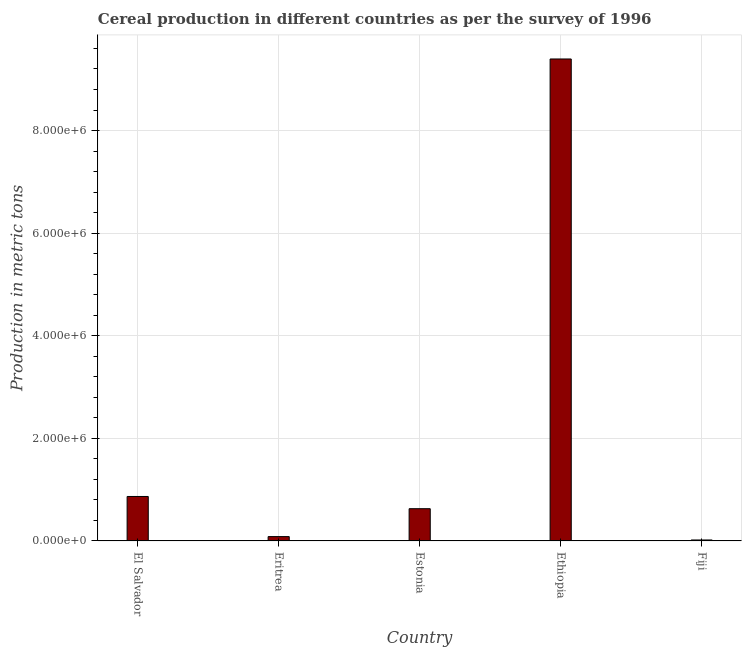Does the graph contain any zero values?
Your answer should be very brief. No. What is the title of the graph?
Offer a terse response. Cereal production in different countries as per the survey of 1996. What is the label or title of the Y-axis?
Offer a very short reply. Production in metric tons. What is the cereal production in Ethiopia?
Provide a succinct answer. 9.39e+06. Across all countries, what is the maximum cereal production?
Provide a succinct answer. 9.39e+06. Across all countries, what is the minimum cereal production?
Your answer should be compact. 1.94e+04. In which country was the cereal production maximum?
Your answer should be very brief. Ethiopia. In which country was the cereal production minimum?
Make the answer very short. Fiji. What is the sum of the cereal production?
Your answer should be very brief. 1.10e+07. What is the difference between the cereal production in El Salvador and Ethiopia?
Keep it short and to the point. -8.53e+06. What is the average cereal production per country?
Keep it short and to the point. 2.20e+06. What is the median cereal production?
Your answer should be very brief. 6.29e+05. What is the ratio of the cereal production in Eritrea to that in Estonia?
Your answer should be compact. 0.14. Is the difference between the cereal production in Eritrea and Ethiopia greater than the difference between any two countries?
Keep it short and to the point. No. What is the difference between the highest and the second highest cereal production?
Provide a short and direct response. 8.53e+06. What is the difference between the highest and the lowest cereal production?
Ensure brevity in your answer.  9.38e+06. In how many countries, is the cereal production greater than the average cereal production taken over all countries?
Provide a short and direct response. 1. Are the values on the major ticks of Y-axis written in scientific E-notation?
Your answer should be very brief. Yes. What is the Production in metric tons in El Salvador?
Offer a terse response. 8.67e+05. What is the Production in metric tons in Eritrea?
Provide a short and direct response. 8.54e+04. What is the Production in metric tons in Estonia?
Give a very brief answer. 6.29e+05. What is the Production in metric tons in Ethiopia?
Provide a short and direct response. 9.39e+06. What is the Production in metric tons in Fiji?
Your answer should be compact. 1.94e+04. What is the difference between the Production in metric tons in El Salvador and Eritrea?
Provide a succinct answer. 7.82e+05. What is the difference between the Production in metric tons in El Salvador and Estonia?
Provide a succinct answer. 2.38e+05. What is the difference between the Production in metric tons in El Salvador and Ethiopia?
Your answer should be compact. -8.53e+06. What is the difference between the Production in metric tons in El Salvador and Fiji?
Your answer should be very brief. 8.48e+05. What is the difference between the Production in metric tons in Eritrea and Estonia?
Offer a very short reply. -5.44e+05. What is the difference between the Production in metric tons in Eritrea and Ethiopia?
Your answer should be very brief. -9.31e+06. What is the difference between the Production in metric tons in Eritrea and Fiji?
Provide a succinct answer. 6.60e+04. What is the difference between the Production in metric tons in Estonia and Ethiopia?
Your answer should be compact. -8.77e+06. What is the difference between the Production in metric tons in Estonia and Fiji?
Make the answer very short. 6.10e+05. What is the difference between the Production in metric tons in Ethiopia and Fiji?
Offer a terse response. 9.38e+06. What is the ratio of the Production in metric tons in El Salvador to that in Eritrea?
Provide a short and direct response. 10.16. What is the ratio of the Production in metric tons in El Salvador to that in Estonia?
Give a very brief answer. 1.38. What is the ratio of the Production in metric tons in El Salvador to that in Ethiopia?
Offer a very short reply. 0.09. What is the ratio of the Production in metric tons in El Salvador to that in Fiji?
Offer a very short reply. 44.69. What is the ratio of the Production in metric tons in Eritrea to that in Estonia?
Keep it short and to the point. 0.14. What is the ratio of the Production in metric tons in Eritrea to that in Ethiopia?
Make the answer very short. 0.01. What is the ratio of the Production in metric tons in Eritrea to that in Fiji?
Keep it short and to the point. 4.4. What is the ratio of the Production in metric tons in Estonia to that in Ethiopia?
Offer a terse response. 0.07. What is the ratio of the Production in metric tons in Estonia to that in Fiji?
Your answer should be compact. 32.42. What is the ratio of the Production in metric tons in Ethiopia to that in Fiji?
Keep it short and to the point. 484.06. 